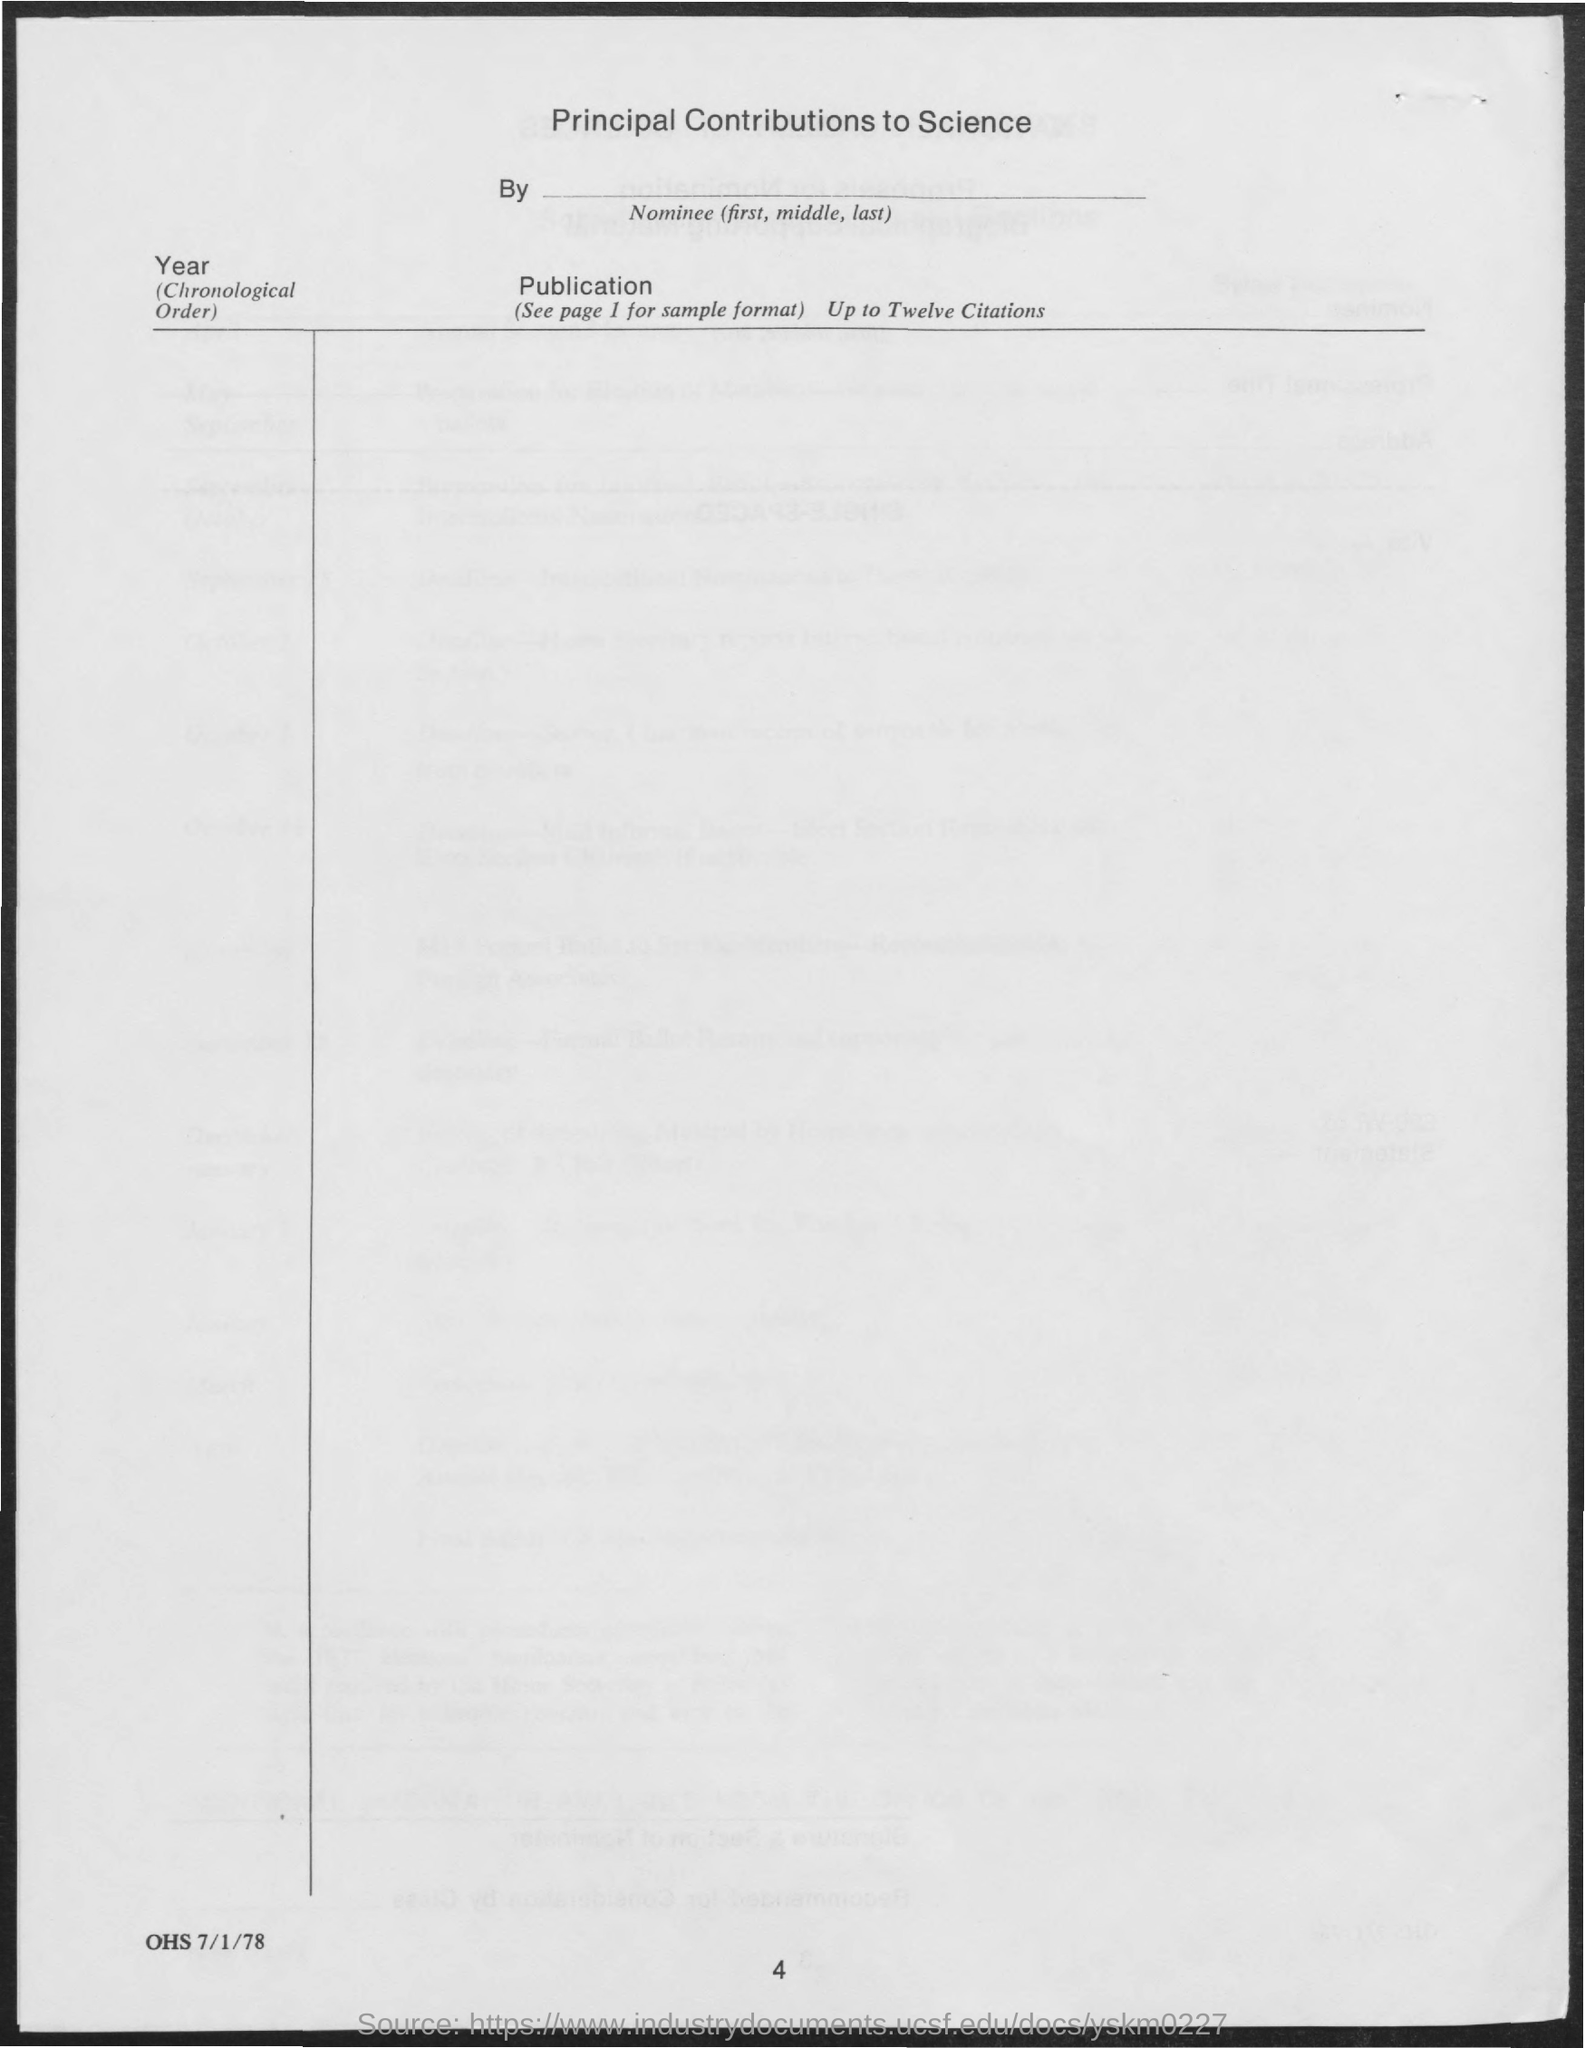What is the title?
Provide a succinct answer. Principal contributions to science. What is the page number?
Your answer should be very brief. 4. What is the heading for second column?
Provide a succinct answer. Publication. In what order the year to be mentioned?
Provide a short and direct response. Chronological order. 